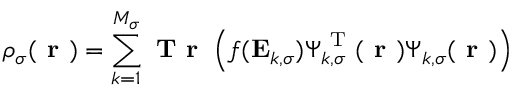<formula> <loc_0><loc_0><loc_500><loc_500>\rho _ { \sigma } ( r ) = \sum _ { k = 1 } ^ { M _ { \sigma } } T r \left ( f ( E _ { k , \sigma } ) \Psi _ { k , \sigma } ^ { T } ( r ) \Psi _ { k , \sigma } ( r ) \right )</formula> 